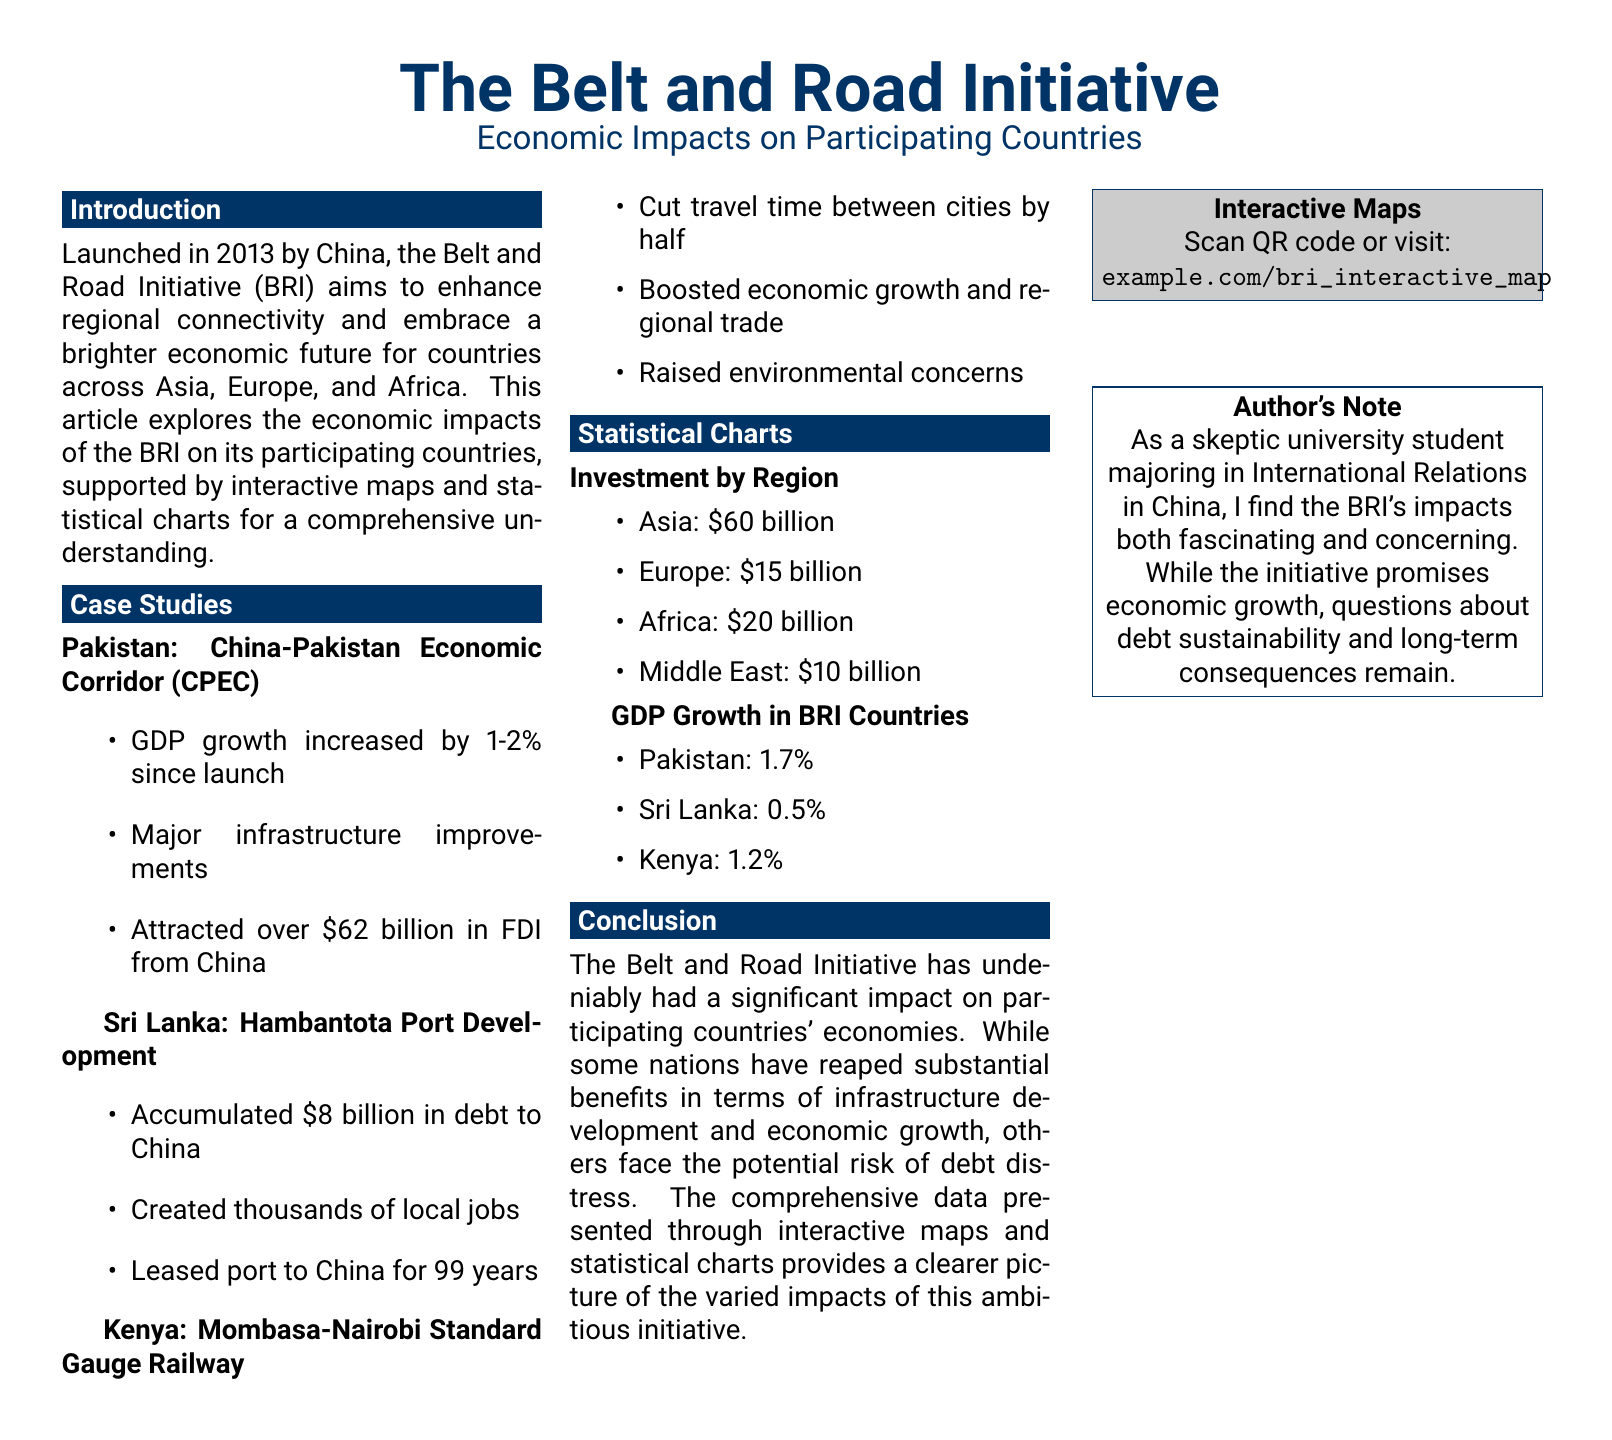What year was the Belt and Road Initiative launched? The document mentions that the BRI was launched in 2013.
Answer: 2013 What is the GDP growth increase for Pakistan since the BRI launch? The document states that Pakistan's GDP growth increased by 1-2% since the launch of BRI.
Answer: 1-2% How much debt has Sri Lanka accumulated due to the Hambantota Port Development? The document specifies that Sri Lanka accumulated $8 billion in debt to China for the port development.
Answer: $8 billion What is the total investment by Europe in the BRI? According to the document, the investment by Europe is listed as $15 billion.
Answer: $15 billion Which country experienced a 1.2% increase in GDP growth due to the BRI? The document indicates that Kenya experienced a 1.2% GDP growth from the BRI.
Answer: Kenya What is the main concern raised by the development in Kenya? The document notes that the development in Kenya raised environmental concerns.
Answer: Environmental concerns What type of economic benefit did the CPEC bring to Pakistan? The document lists significant infrastructure improvements as a benefit of the CPEC in Pakistan.
Answer: Infrastructure improvements How long is the lease of the Hambantota port to China? The document states that the port is leased to China for 99 years.
Answer: 99 years What method is used to access the interactive maps? The document mentions scanning a QR code or visiting a website for interactive maps.
Answer: QR code or website 